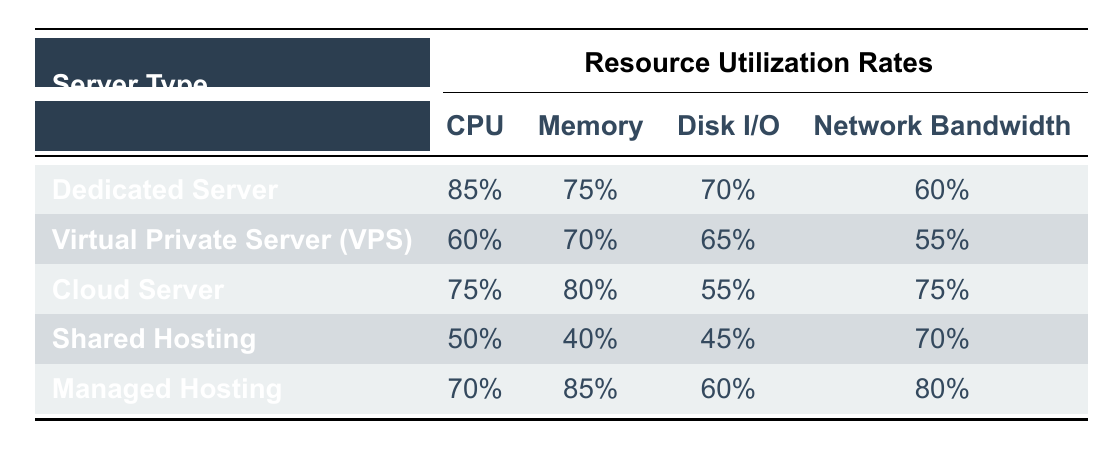What is the CPU utilization rate for Shared Hosting? The CPU utilization rate for Shared Hosting can be found in the table. It specifically states "50%" for this server type.
Answer: 50% Which server type has the highest Memory utilization rate? Searching through the Memory column in the table, Managed Hosting has the highest rate at "85%."
Answer: 85% What is the difference in Disk I/O utilization rates between Dedicated Server and Cloud Server? The Disk I/O for Dedicated Server is "70%" and for Cloud Server is "55%." The difference is calculated as 70% - 55% = 15%.
Answer: 15% Does Cloud Server have a higher Network Bandwidth utilization rate than Virtual Private Server (VPS)? Checking the Network Bandwidth values, Cloud Server has "75%" and VPS has "55%." Since 75% is greater than 55%, the statement is true.
Answer: Yes What is the average CPU utilization rate across all server types? The CPU utilization rates are 85%, 60%, 75%, 50%, and 70%. First, sum these values: 85 + 60 + 75 + 50 + 70 = 340. There are 5 server types, so the average is 340 / 5 = 68%.
Answer: 68% Which server type has the lowest Network Bandwidth utilization rate? By reviewing the Network Bandwidth column, Shared Hosting shows "70%," which is higher than VPS's "55%," making VPS the lowest at "55%."
Answer: Virtual Private Server (VPS) Is the Memory utilization rate for Managed Hosting higher than that of Cloud Server? The Memory utilization for Managed Hosting is "85%" and for Cloud Server it is "80%." Since 85% is greater than 80%, the statement is true.
Answer: Yes What is the overall utilization of Disk I/O for all server types combined? The Disk I/O rates are 70%, 65%, 55%, 45%, and 60%. Adding these yields: 70 + 65 + 55 + 45 + 60 = 295. For the average, divide by 5: 295 / 5 = 59%.
Answer: 59% 